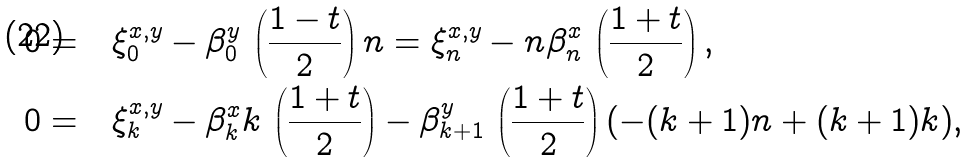<formula> <loc_0><loc_0><loc_500><loc_500>0 = & \quad \xi _ { 0 } ^ { x , y } - \beta _ { 0 } ^ { y } \, \left ( \frac { 1 - t } { 2 } \right ) n = \xi _ { n } ^ { x , y } - n \beta _ { n } ^ { x } \, \left ( \frac { 1 + t } { 2 } \right ) , \\ 0 = & \quad \xi _ { k } ^ { x , y } - \beta _ { k } ^ { x } k \, \left ( \frac { 1 + t } { 2 } \right ) - \beta _ { k + 1 } ^ { y } \, \left ( \frac { 1 + t } { 2 } \right ) ( - ( k + 1 ) n + ( k + 1 ) k ) ,</formula> 